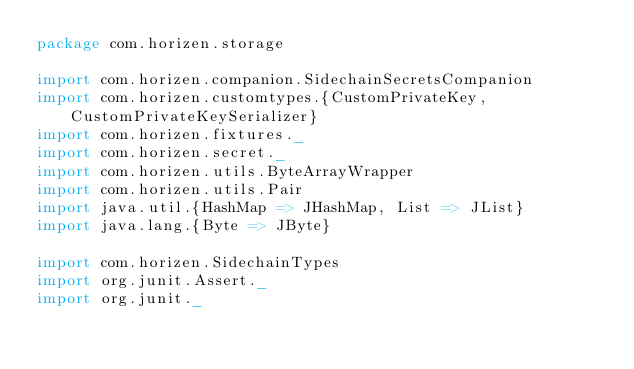Convert code to text. <code><loc_0><loc_0><loc_500><loc_500><_Scala_>package com.horizen.storage

import com.horizen.companion.SidechainSecretsCompanion
import com.horizen.customtypes.{CustomPrivateKey, CustomPrivateKeySerializer}
import com.horizen.fixtures._
import com.horizen.secret._
import com.horizen.utils.ByteArrayWrapper
import com.horizen.utils.Pair
import java.util.{HashMap => JHashMap, List => JList}
import java.lang.{Byte => JByte}

import com.horizen.SidechainTypes
import org.junit.Assert._
import org.junit._</code> 